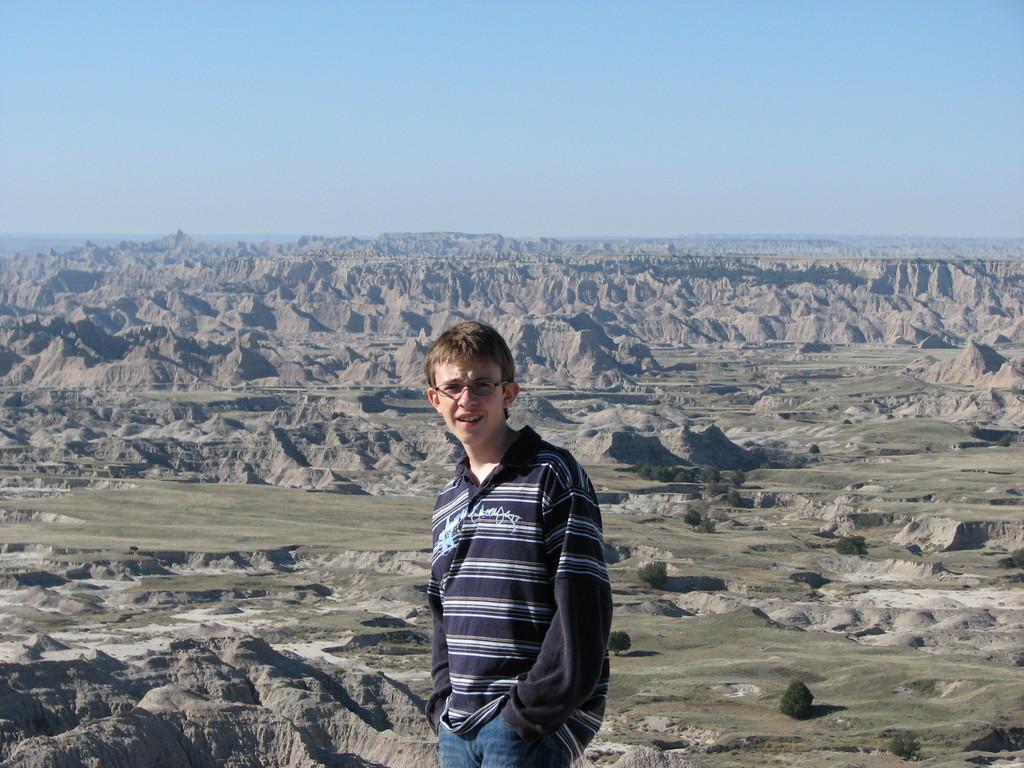How would you summarize this image in a sentence or two? In this image, we can see a boy standing and he is wearing specs, in the background we can see some plants and at the top we can see the blue sky. 